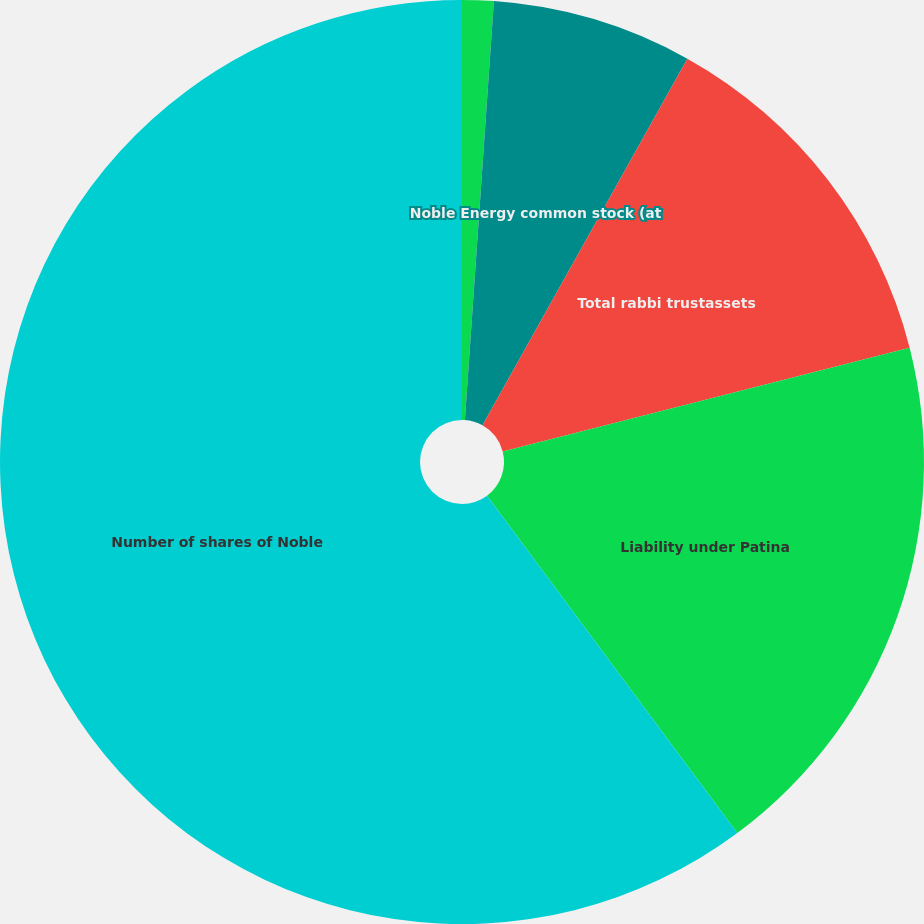<chart> <loc_0><loc_0><loc_500><loc_500><pie_chart><fcel>Mutual fund investments<fcel>Noble Energy common stock (at<fcel>Total rabbi trustassets<fcel>Liability under Patina<fcel>Number of shares of Noble<nl><fcel>1.1%<fcel>7.01%<fcel>12.91%<fcel>18.82%<fcel>60.16%<nl></chart> 